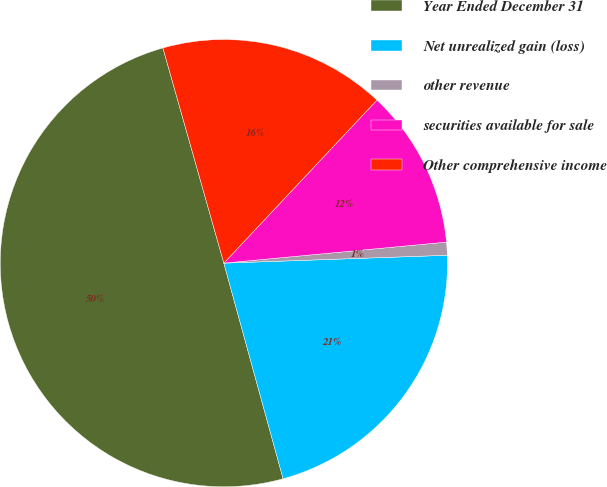Convert chart to OTSL. <chart><loc_0><loc_0><loc_500><loc_500><pie_chart><fcel>Year Ended December 31<fcel>Net unrealized gain (loss)<fcel>other revenue<fcel>securities available for sale<fcel>Other comprehensive income<nl><fcel>49.87%<fcel>21.29%<fcel>0.94%<fcel>11.5%<fcel>16.39%<nl></chart> 